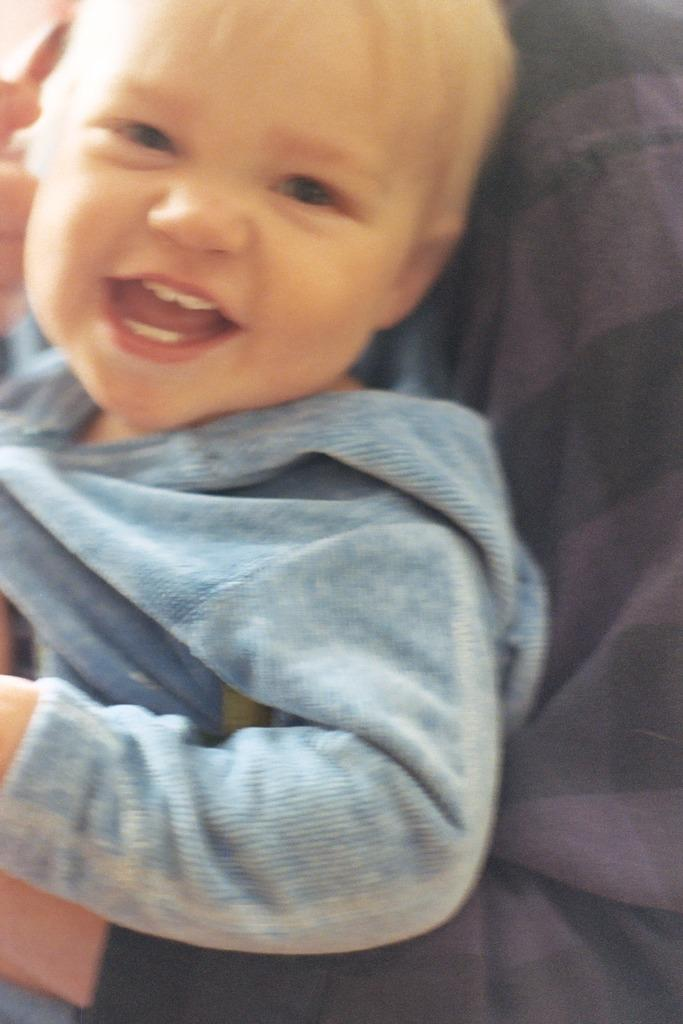What is the main subject of the image? The main subject of the image is a person holding a baby. How does the baby appear to be feeling in the image? The baby is smiling in the image. Where is the faucet located in the image? There is no faucet present in the image. What is the boy's name in the image? There is no boy present in the image, only a person holding a baby. 